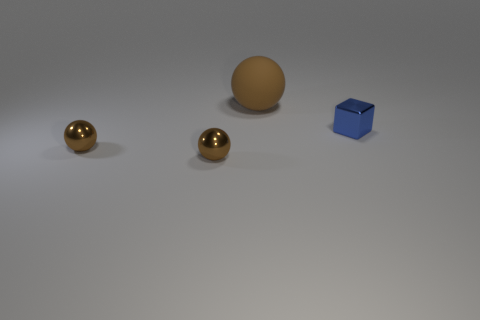Add 2 balls. How many objects exist? 6 Subtract all balls. How many objects are left? 1 Subtract 0 purple blocks. How many objects are left? 4 Subtract all big gray rubber balls. Subtract all brown matte objects. How many objects are left? 3 Add 1 big brown spheres. How many big brown spheres are left? 2 Add 1 large brown matte balls. How many large brown matte balls exist? 2 